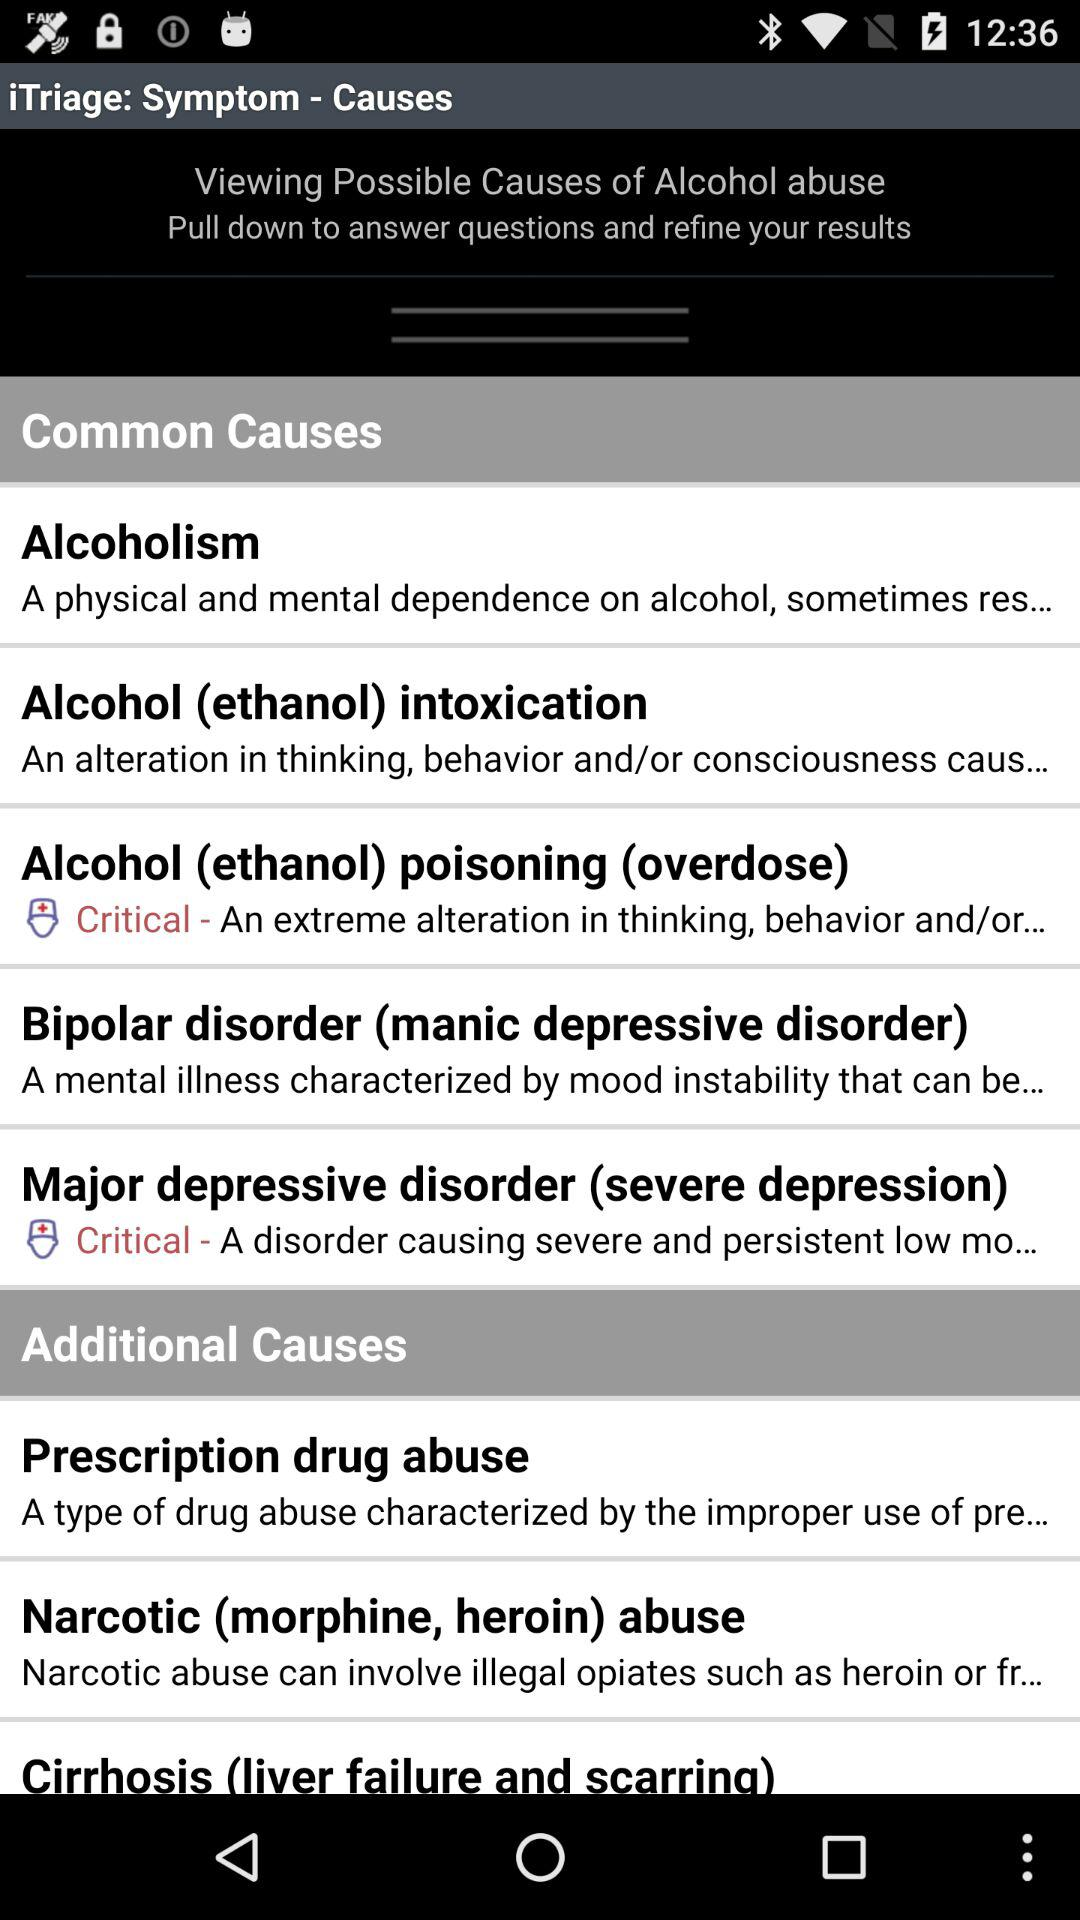What's another name for bipolar disorder? Another name for bipolar disorder is manic depressive disorder. 